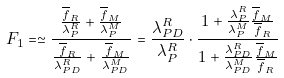Convert formula to latex. <formula><loc_0><loc_0><loc_500><loc_500>F _ { 1 } = \simeq \frac { \frac { \overline { f } _ { R } } { \lambda _ { P } ^ { R } } + \frac { \overline { f } _ { M } } { \lambda _ { P } ^ { M } } } { \frac { \overline { f } _ { R } } { \lambda _ { P D } ^ { R } } + \frac { \overline { f } _ { M } } { \lambda _ { P D } ^ { M } } } = \frac { \lambda _ { P D } ^ { R } } { \lambda _ { P } ^ { R } } \cdot \frac { 1 + \frac { \lambda _ { P } ^ { R } } { \lambda _ { P } ^ { M } } \frac { \overline { f } _ { M } } { \overline { f } _ { R } } } { 1 + \frac { \lambda _ { P D } ^ { R } } { \lambda _ { P D } ^ { M } } \frac { \overline { f } _ { M } } { \overline { f } _ { R } } }</formula> 